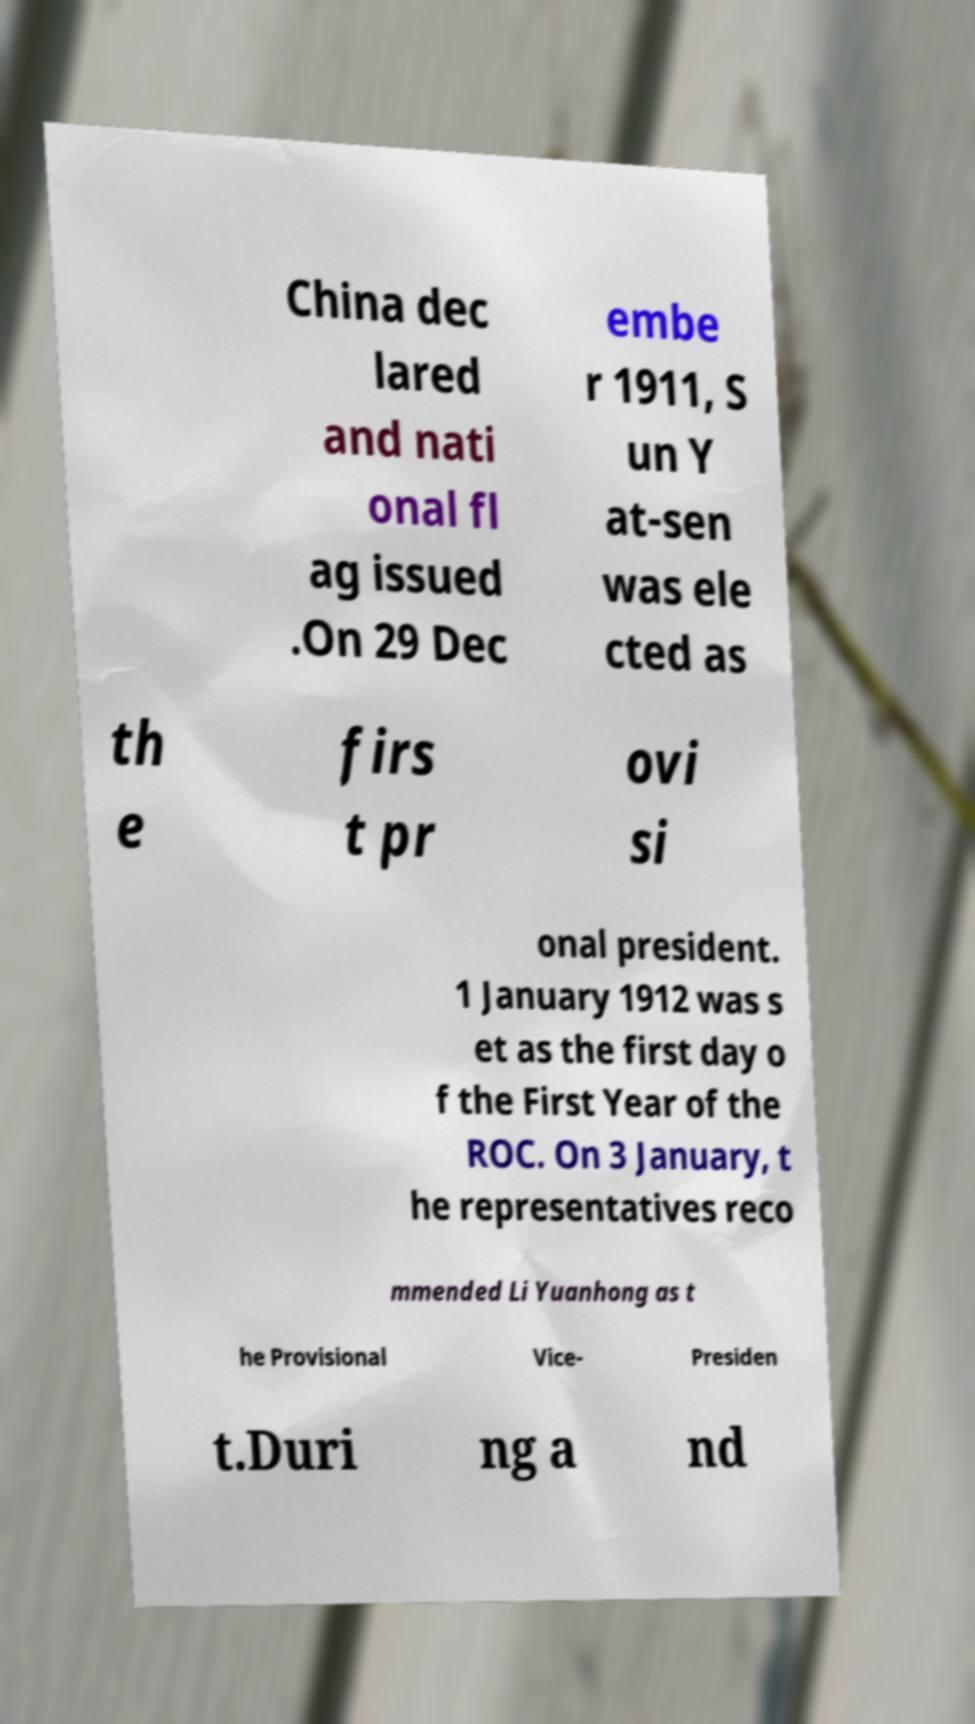Can you accurately transcribe the text from the provided image for me? China dec lared and nati onal fl ag issued .On 29 Dec embe r 1911, S un Y at-sen was ele cted as th e firs t pr ovi si onal president. 1 January 1912 was s et as the first day o f the First Year of the ROC. On 3 January, t he representatives reco mmended Li Yuanhong as t he Provisional Vice- Presiden t.Duri ng a nd 